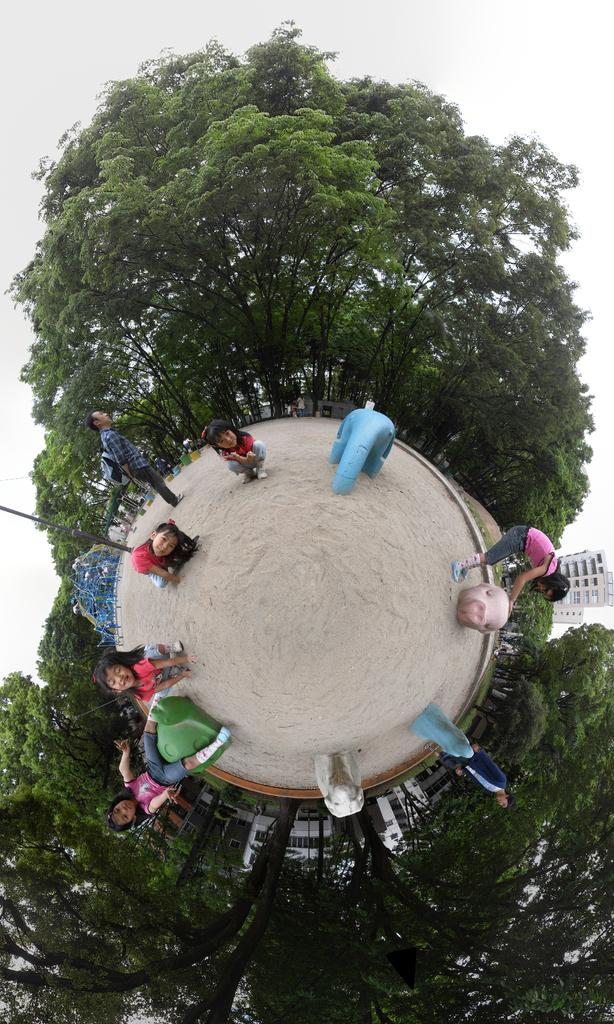What type of image is shown in the picture? The image is a 360-degree panorama. What can be seen on the playground in the image? There are kids standing on the playground. What is visible in the background of the image? There are trees in the background. What structure is located on the right side of the image? There is a building on the right side of the image. What is visible at the top of the image? The sky is visible in the image. Where is the table located in the image? There is no table present in the image. What type of print can be seen on the kids' shirts in the image? There is no print visible on the kids' shirts in the image. 